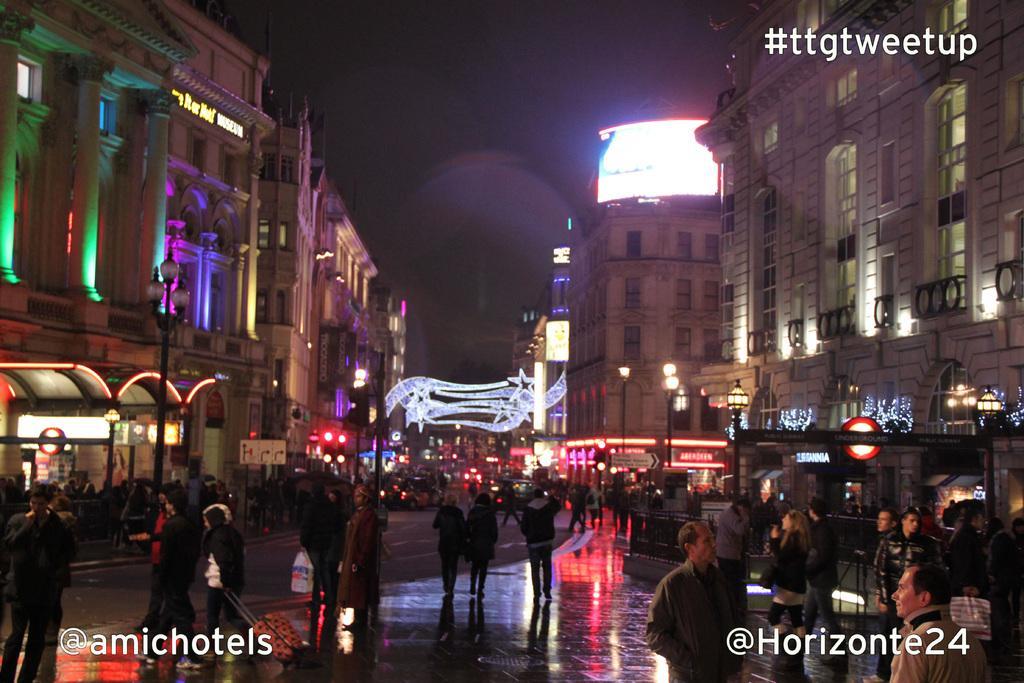Can you describe this image briefly? In this picture I can see group of people standing, there are buildings, poles, lights, boards and there are watermarks on the image. 